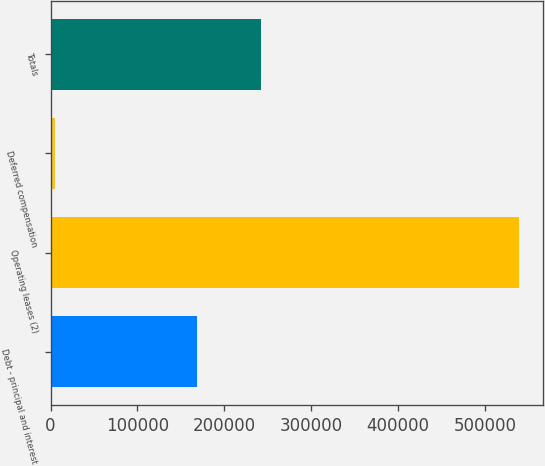Convert chart. <chart><loc_0><loc_0><loc_500><loc_500><bar_chart><fcel>Debt - principal and interest<fcel>Operating leases (2)<fcel>Deferred compensation<fcel>Totals<nl><fcel>168900<fcel>539550<fcel>5185<fcel>241940<nl></chart> 